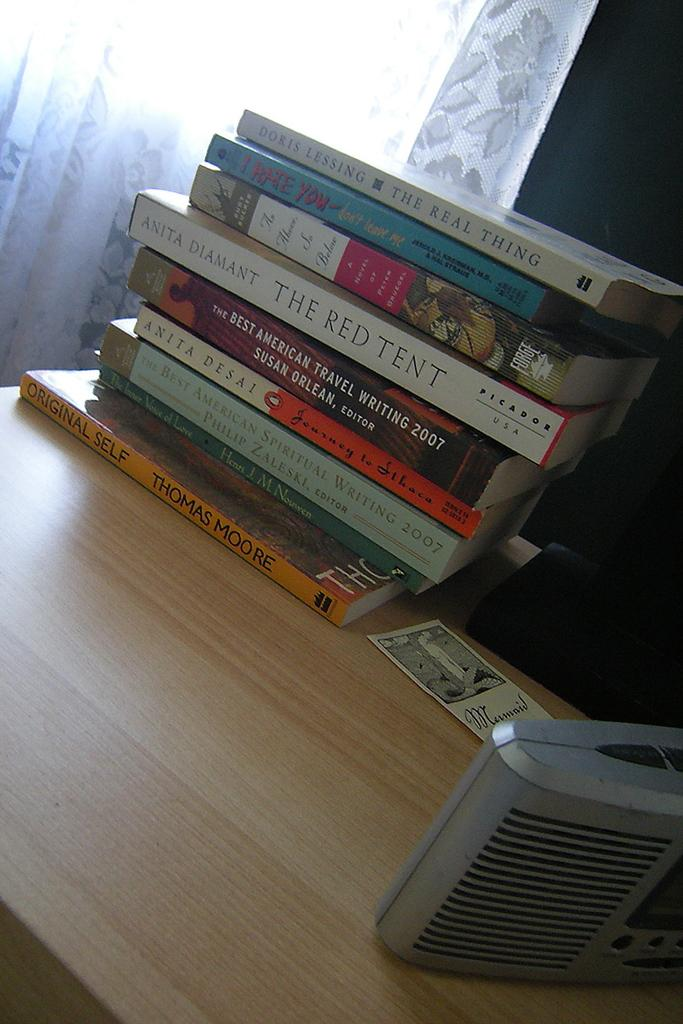<image>
Summarize the visual content of the image. A pile of books, one of which is called The Red Tent. 